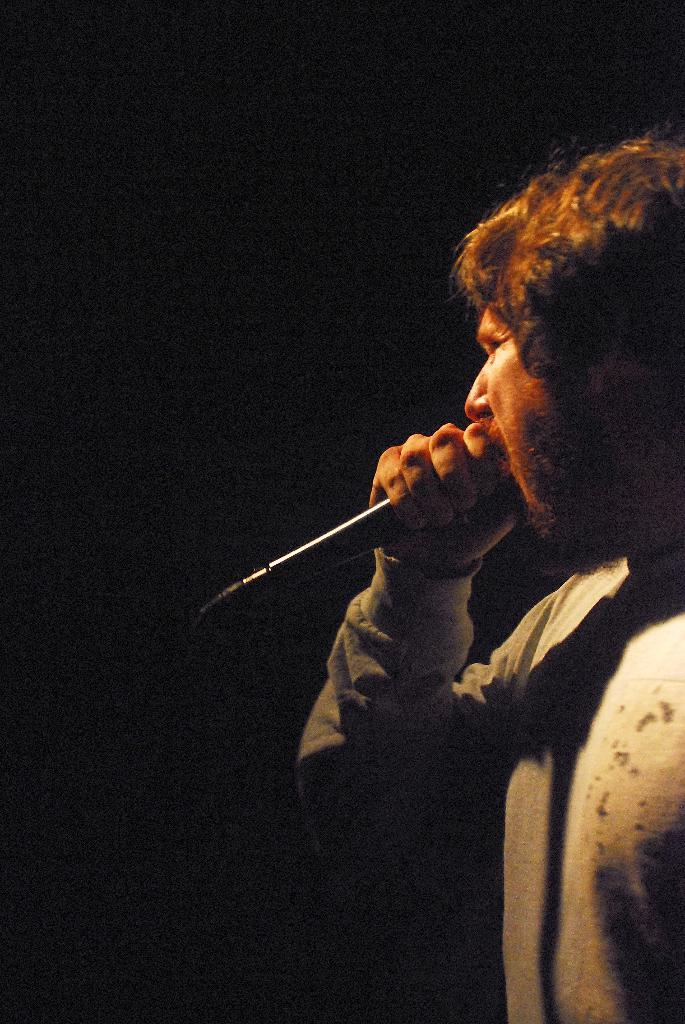What is the main subject of the image? There is a person in the image. What is the person holding in the image? The person is holding a microphone. What time is displayed on the hour in the image? There is no hour or clock present in the image. Is there a bomb visible in the image? There is no bomb present in the image. Can you see a lock on any object in the image? There is no lock present in the image. 